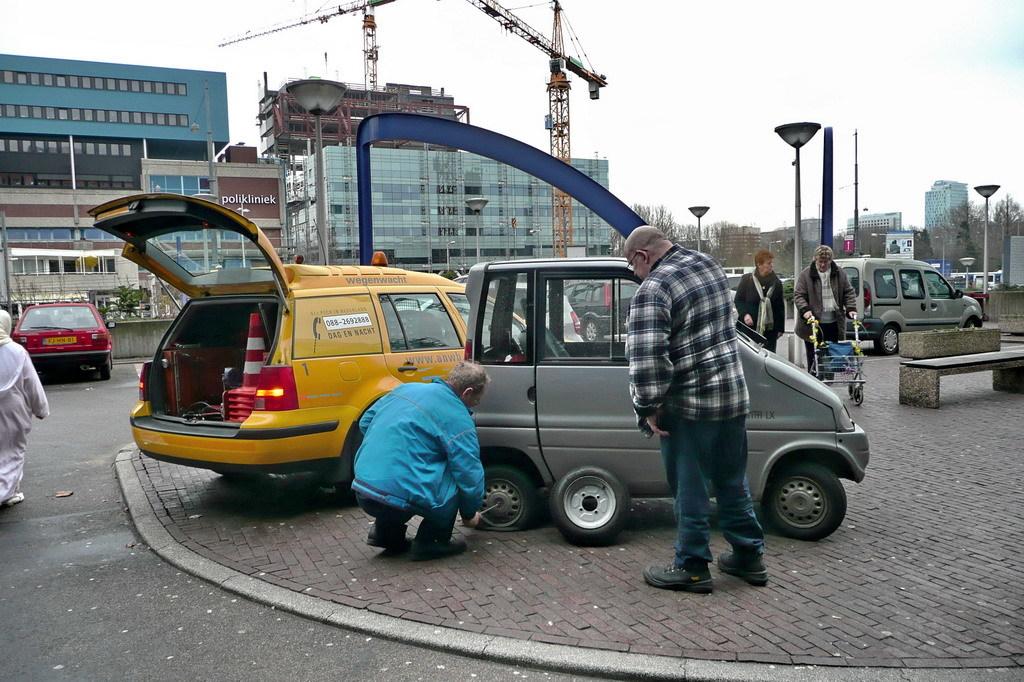What is the name of the building in the background?
Keep it short and to the point. Polikliniek. What is the phone number on the yellow car?
Provide a short and direct response. 088-2692888. 